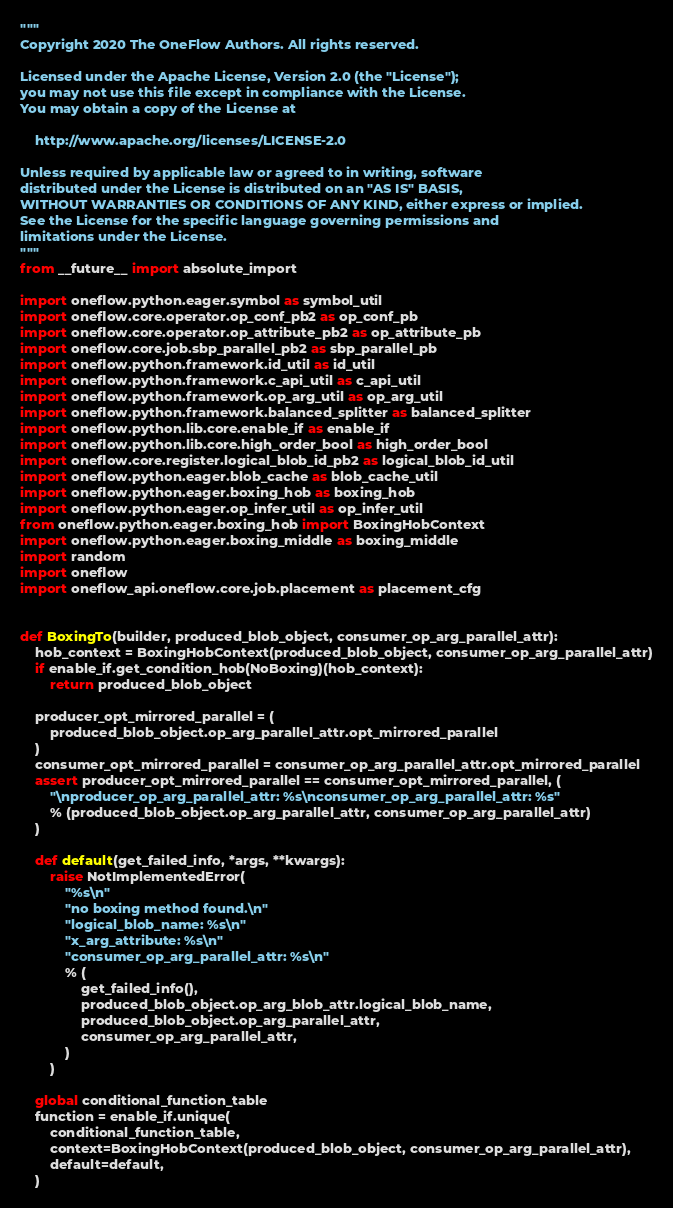<code> <loc_0><loc_0><loc_500><loc_500><_Python_>"""
Copyright 2020 The OneFlow Authors. All rights reserved.

Licensed under the Apache License, Version 2.0 (the "License");
you may not use this file except in compliance with the License.
You may obtain a copy of the License at

    http://www.apache.org/licenses/LICENSE-2.0

Unless required by applicable law or agreed to in writing, software
distributed under the License is distributed on an "AS IS" BASIS,
WITHOUT WARRANTIES OR CONDITIONS OF ANY KIND, either express or implied.
See the License for the specific language governing permissions and
limitations under the License.
"""
from __future__ import absolute_import

import oneflow.python.eager.symbol as symbol_util
import oneflow.core.operator.op_conf_pb2 as op_conf_pb
import oneflow.core.operator.op_attribute_pb2 as op_attribute_pb
import oneflow.core.job.sbp_parallel_pb2 as sbp_parallel_pb
import oneflow.python.framework.id_util as id_util
import oneflow.python.framework.c_api_util as c_api_util
import oneflow.python.framework.op_arg_util as op_arg_util
import oneflow.python.framework.balanced_splitter as balanced_splitter
import oneflow.python.lib.core.enable_if as enable_if
import oneflow.python.lib.core.high_order_bool as high_order_bool
import oneflow.core.register.logical_blob_id_pb2 as logical_blob_id_util
import oneflow.python.eager.blob_cache as blob_cache_util
import oneflow.python.eager.boxing_hob as boxing_hob
import oneflow.python.eager.op_infer_util as op_infer_util
from oneflow.python.eager.boxing_hob import BoxingHobContext
import oneflow.python.eager.boxing_middle as boxing_middle
import random
import oneflow
import oneflow_api.oneflow.core.job.placement as placement_cfg


def BoxingTo(builder, produced_blob_object, consumer_op_arg_parallel_attr):
    hob_context = BoxingHobContext(produced_blob_object, consumer_op_arg_parallel_attr)
    if enable_if.get_condition_hob(NoBoxing)(hob_context):
        return produced_blob_object

    producer_opt_mirrored_parallel = (
        produced_blob_object.op_arg_parallel_attr.opt_mirrored_parallel
    )
    consumer_opt_mirrored_parallel = consumer_op_arg_parallel_attr.opt_mirrored_parallel
    assert producer_opt_mirrored_parallel == consumer_opt_mirrored_parallel, (
        "\nproducer_op_arg_parallel_attr: %s\nconsumer_op_arg_parallel_attr: %s"
        % (produced_blob_object.op_arg_parallel_attr, consumer_op_arg_parallel_attr)
    )

    def default(get_failed_info, *args, **kwargs):
        raise NotImplementedError(
            "%s\n"
            "no boxing method found.\n"
            "logical_blob_name: %s\n"
            "x_arg_attribute: %s\n"
            "consumer_op_arg_parallel_attr: %s\n"
            % (
                get_failed_info(),
                produced_blob_object.op_arg_blob_attr.logical_blob_name,
                produced_blob_object.op_arg_parallel_attr,
                consumer_op_arg_parallel_attr,
            )
        )

    global conditional_function_table
    function = enable_if.unique(
        conditional_function_table,
        context=BoxingHobContext(produced_blob_object, consumer_op_arg_parallel_attr),
        default=default,
    )</code> 